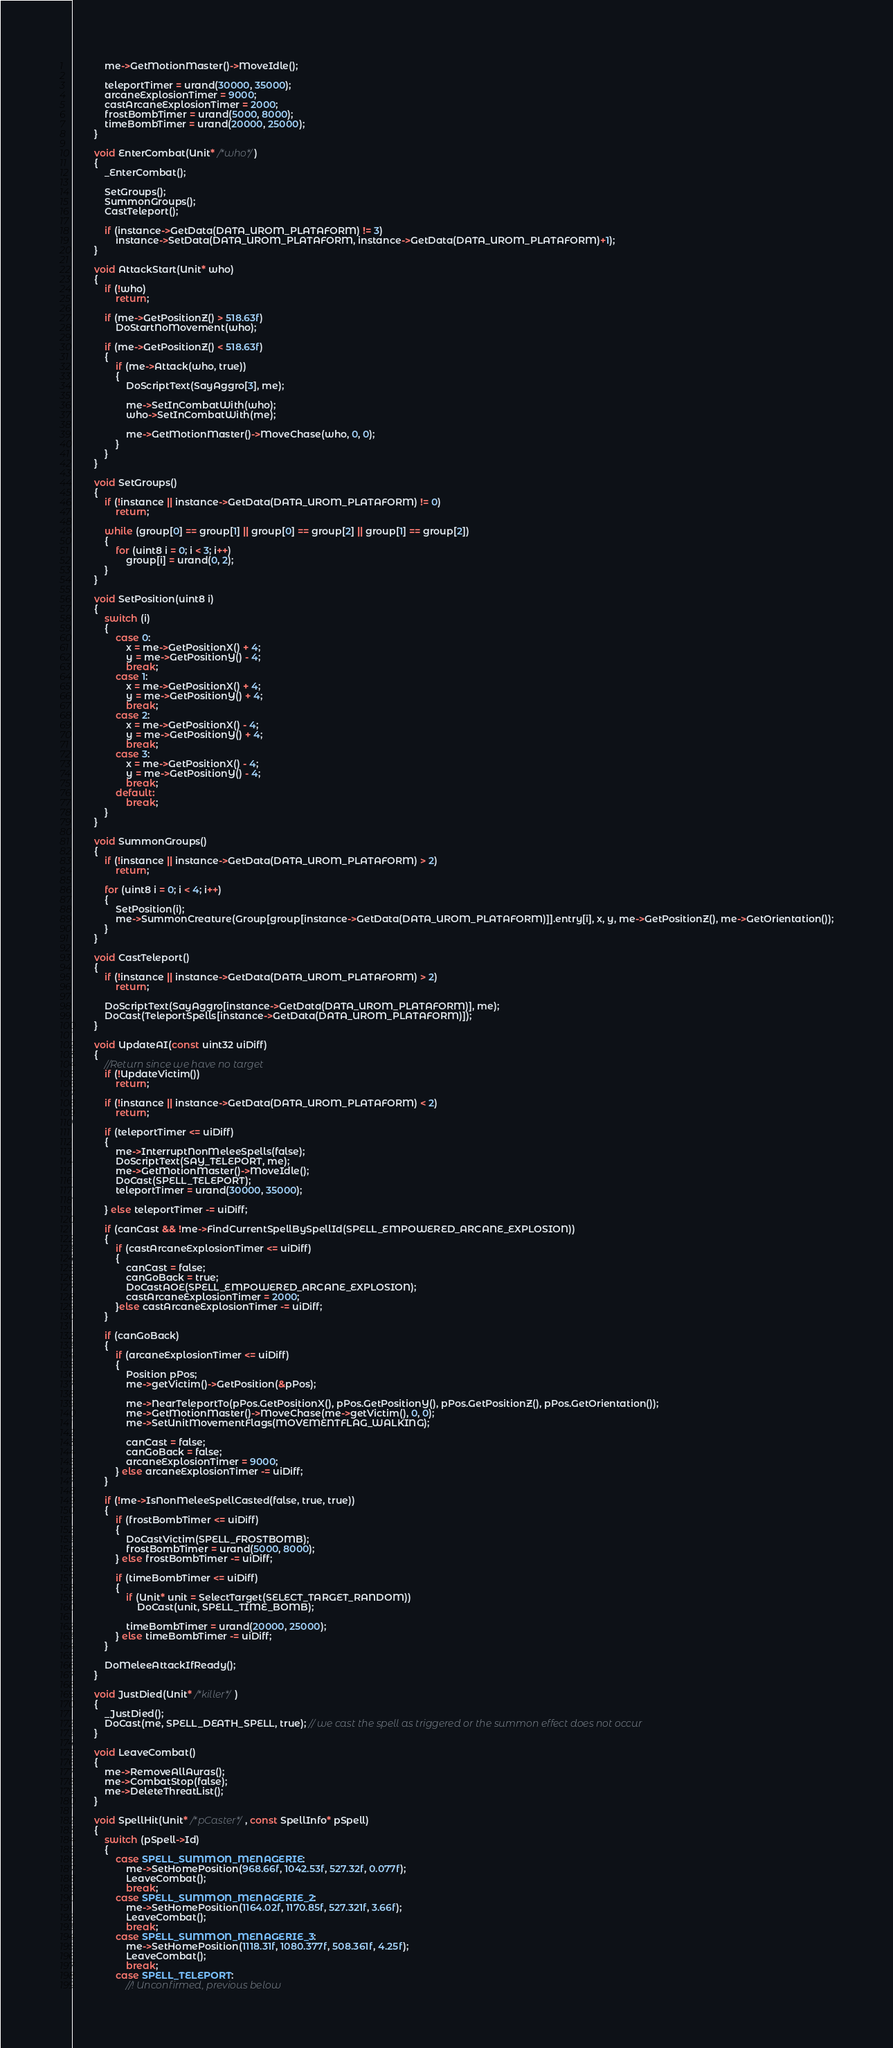Convert code to text. <code><loc_0><loc_0><loc_500><loc_500><_C++_>
            me->GetMotionMaster()->MoveIdle();

            teleportTimer = urand(30000, 35000);
            arcaneExplosionTimer = 9000;
            castArcaneExplosionTimer = 2000;
            frostBombTimer = urand(5000, 8000);
            timeBombTimer = urand(20000, 25000);
        }

        void EnterCombat(Unit* /*who*/)
        {
            _EnterCombat();

            SetGroups();
            SummonGroups();
            CastTeleport();

            if (instance->GetData(DATA_UROM_PLATAFORM) != 3)
                instance->SetData(DATA_UROM_PLATAFORM, instance->GetData(DATA_UROM_PLATAFORM)+1);
        }

        void AttackStart(Unit* who)
        {
            if (!who)
                return;

            if (me->GetPositionZ() > 518.63f)
                DoStartNoMovement(who);

            if (me->GetPositionZ() < 518.63f)
            {
                if (me->Attack(who, true))
                {
                    DoScriptText(SayAggro[3], me);

                    me->SetInCombatWith(who);
                    who->SetInCombatWith(me);

                    me->GetMotionMaster()->MoveChase(who, 0, 0);
                }
            }
        }

        void SetGroups()
        {
            if (!instance || instance->GetData(DATA_UROM_PLATAFORM) != 0)
                return;

            while (group[0] == group[1] || group[0] == group[2] || group[1] == group[2])
            {
                for (uint8 i = 0; i < 3; i++)
                    group[i] = urand(0, 2);
            }
        }

        void SetPosition(uint8 i)
        {
            switch (i)
            {
                case 0:
                    x = me->GetPositionX() + 4;
                    y = me->GetPositionY() - 4;
                    break;
                case 1:
                    x = me->GetPositionX() + 4;
                    y = me->GetPositionY() + 4;
                    break;
                case 2:
                    x = me->GetPositionX() - 4;
                    y = me->GetPositionY() + 4;
                    break;
                case 3:
                    x = me->GetPositionX() - 4;
                    y = me->GetPositionY() - 4;
                    break;
                default:
                    break;
            }
        }

        void SummonGroups()
        {
            if (!instance || instance->GetData(DATA_UROM_PLATAFORM) > 2)
                return;

            for (uint8 i = 0; i < 4; i++)
            {
                SetPosition(i);
                me->SummonCreature(Group[group[instance->GetData(DATA_UROM_PLATAFORM)]].entry[i], x, y, me->GetPositionZ(), me->GetOrientation());
            }
        }

        void CastTeleport()
        {
            if (!instance || instance->GetData(DATA_UROM_PLATAFORM) > 2)
                return;

            DoScriptText(SayAggro[instance->GetData(DATA_UROM_PLATAFORM)], me);
            DoCast(TeleportSpells[instance->GetData(DATA_UROM_PLATAFORM)]);
        }

        void UpdateAI(const uint32 uiDiff)
        {
            //Return since we have no target
            if (!UpdateVictim())
                return;

            if (!instance || instance->GetData(DATA_UROM_PLATAFORM) < 2)
                return;

            if (teleportTimer <= uiDiff)
            {
                me->InterruptNonMeleeSpells(false);
                DoScriptText(SAY_TELEPORT, me);
                me->GetMotionMaster()->MoveIdle();
                DoCast(SPELL_TELEPORT);
                teleportTimer = urand(30000, 35000);

            } else teleportTimer -= uiDiff;

            if (canCast && !me->FindCurrentSpellBySpellId(SPELL_EMPOWERED_ARCANE_EXPLOSION))
            {
                if (castArcaneExplosionTimer <= uiDiff)
                {
                    canCast = false;
                    canGoBack = true;
                    DoCastAOE(SPELL_EMPOWERED_ARCANE_EXPLOSION);
                    castArcaneExplosionTimer = 2000;
                }else castArcaneExplosionTimer -= uiDiff;
            }

            if (canGoBack)
            {
                if (arcaneExplosionTimer <= uiDiff)
                {
                    Position pPos;
                    me->getVictim()->GetPosition(&pPos);

                    me->NearTeleportTo(pPos.GetPositionX(), pPos.GetPositionY(), pPos.GetPositionZ(), pPos.GetOrientation());
                    me->GetMotionMaster()->MoveChase(me->getVictim(), 0, 0);
                    me->SetUnitMovementFlags(MOVEMENTFLAG_WALKING);

                    canCast = false;
                    canGoBack = false;
                    arcaneExplosionTimer = 9000;
                } else arcaneExplosionTimer -= uiDiff;
            }

            if (!me->IsNonMeleeSpellCasted(false, true, true))
            {
                if (frostBombTimer <= uiDiff)
                {
                    DoCastVictim(SPELL_FROSTBOMB);
                    frostBombTimer = urand(5000, 8000);
                } else frostBombTimer -= uiDiff;

                if (timeBombTimer <= uiDiff)
                {
                    if (Unit* unit = SelectTarget(SELECT_TARGET_RANDOM))
                        DoCast(unit, SPELL_TIME_BOMB);

                    timeBombTimer = urand(20000, 25000);
                } else timeBombTimer -= uiDiff;
            }

            DoMeleeAttackIfReady();
        }

        void JustDied(Unit* /*killer*/)
        {
            _JustDied();
            DoCast(me, SPELL_DEATH_SPELL, true); // we cast the spell as triggered or the summon effect does not occur
        }

        void LeaveCombat()
        {
            me->RemoveAllAuras();
            me->CombatStop(false);
            me->DeleteThreatList();
        }

        void SpellHit(Unit* /*pCaster*/, const SpellInfo* pSpell)
        {
            switch (pSpell->Id)
            {
                case SPELL_SUMMON_MENAGERIE:
                    me->SetHomePosition(968.66f, 1042.53f, 527.32f, 0.077f);
                    LeaveCombat();
                    break;
                case SPELL_SUMMON_MENAGERIE_2:
                    me->SetHomePosition(1164.02f, 1170.85f, 527.321f, 3.66f);
                    LeaveCombat();
                    break;
                case SPELL_SUMMON_MENAGERIE_3:
                    me->SetHomePosition(1118.31f, 1080.377f, 508.361f, 4.25f);
                    LeaveCombat();
                    break;
                case SPELL_TELEPORT:
                    //! Unconfirmed, previous below</code> 